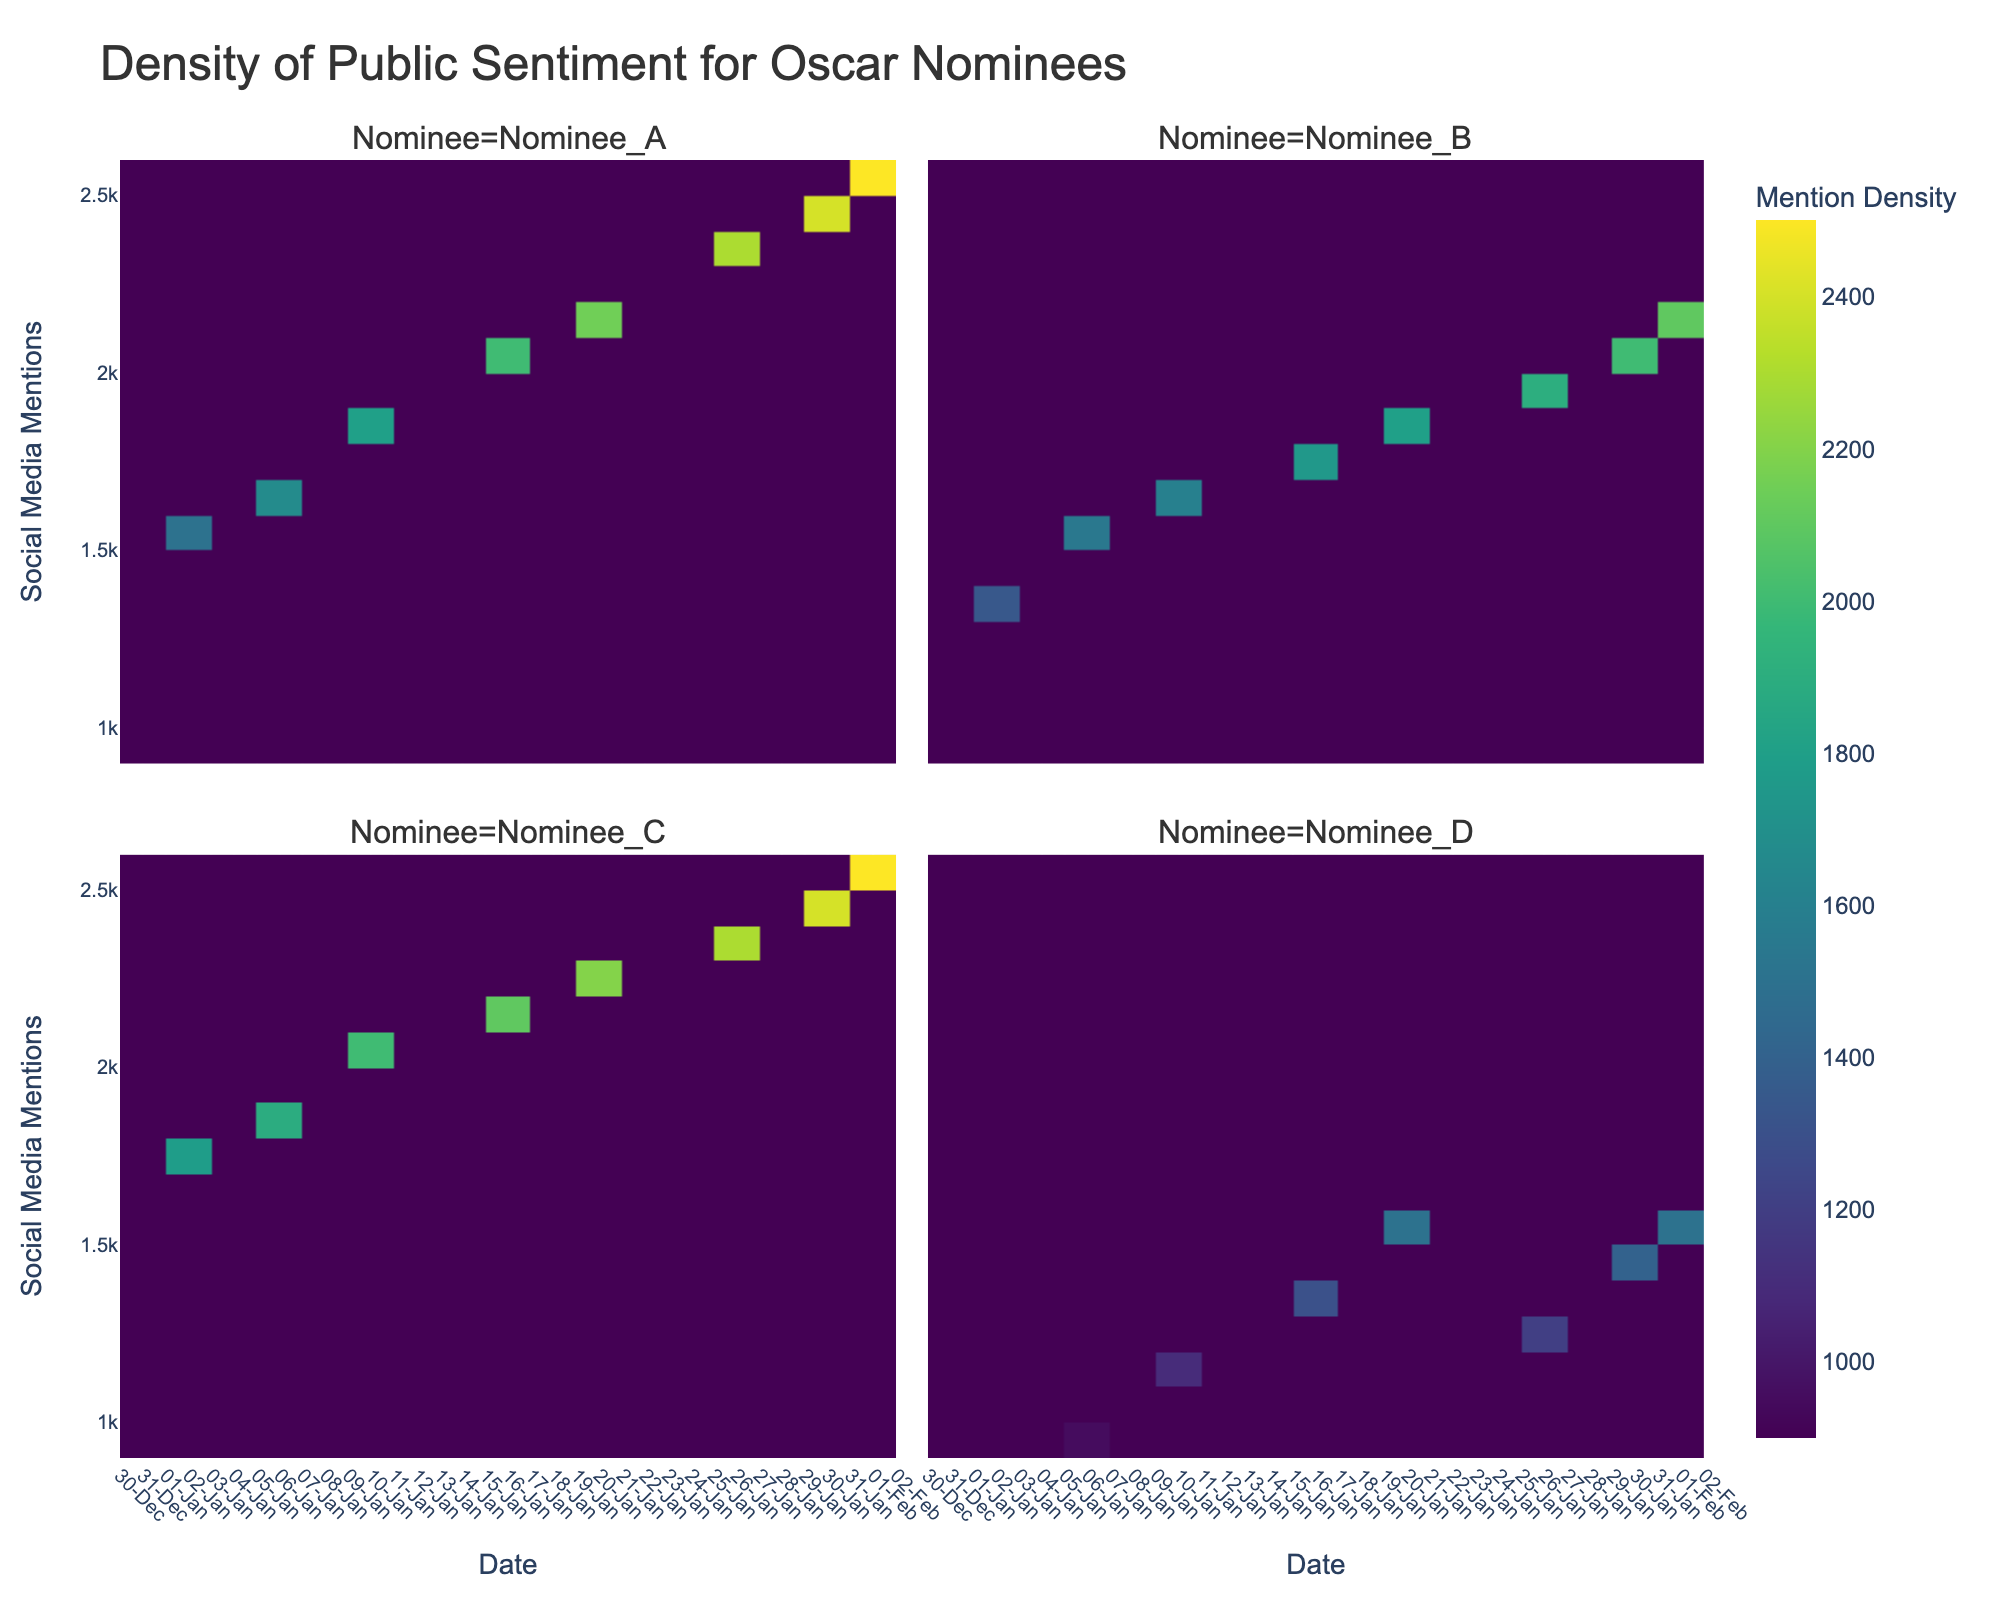What is the title of the plot? The title is usually located at the top of the plot and gives a summary of what the plot is about.
Answer: Density of Public Sentiment for Oscar Nominees Which nominee had the highest mention on February 1st? The density plot includes color-coded blocks representing the density of mentions where darker colors indicate higher value. Nominee_A and Nominee_C reached the highest value.
Answer: Nominee_A and Nominee_C On which date did Nominee_D see their lowest social media mentions? Find the lowest point in the density color pattern for Nominee_D, which will be represented by the lightest color block.
Answer: January 1st How has the social media mentions of Nominee_B changed over January? Look at the density colors for Nominee_B from January 1st to January 30th and compare the trend in color darkness.
Answer: Increased Which nominee had a wider variation in mention density throughout the depicted period? Compare the spread and color variation across dates for each nominee. A wider spread and larger color variation indicate greater differences in mention density.
Answer: Nominee_C Compare the mention density of Nominee_A on January 1st and January 30th. Which date had higher mention density? Compare the color density for Nominee_A on January 1st and January 30th. Darker color indicates higher density.
Answer: January 30th Which date saw an increase in mention density for all nominees equally? Find the date where all nominees present an overall increase in mention density, indicated by darker colors across all their panels.
Answer: January 10th Which nominees show any cyclical trends in their mention density throughout the period? Examine the density plots of each nominee to identify any recurring patterns or alternating periods of high and low density colors.
Answer: Nominee_A and Nominee_C What is the average of social media mentions for Nominee_D towards the start and end of January? Check the average mentions for Nominee_D on January 1st (900) and February 1st (1500), then calculate the mean value of 900 and 1500.
Answer: 1200 